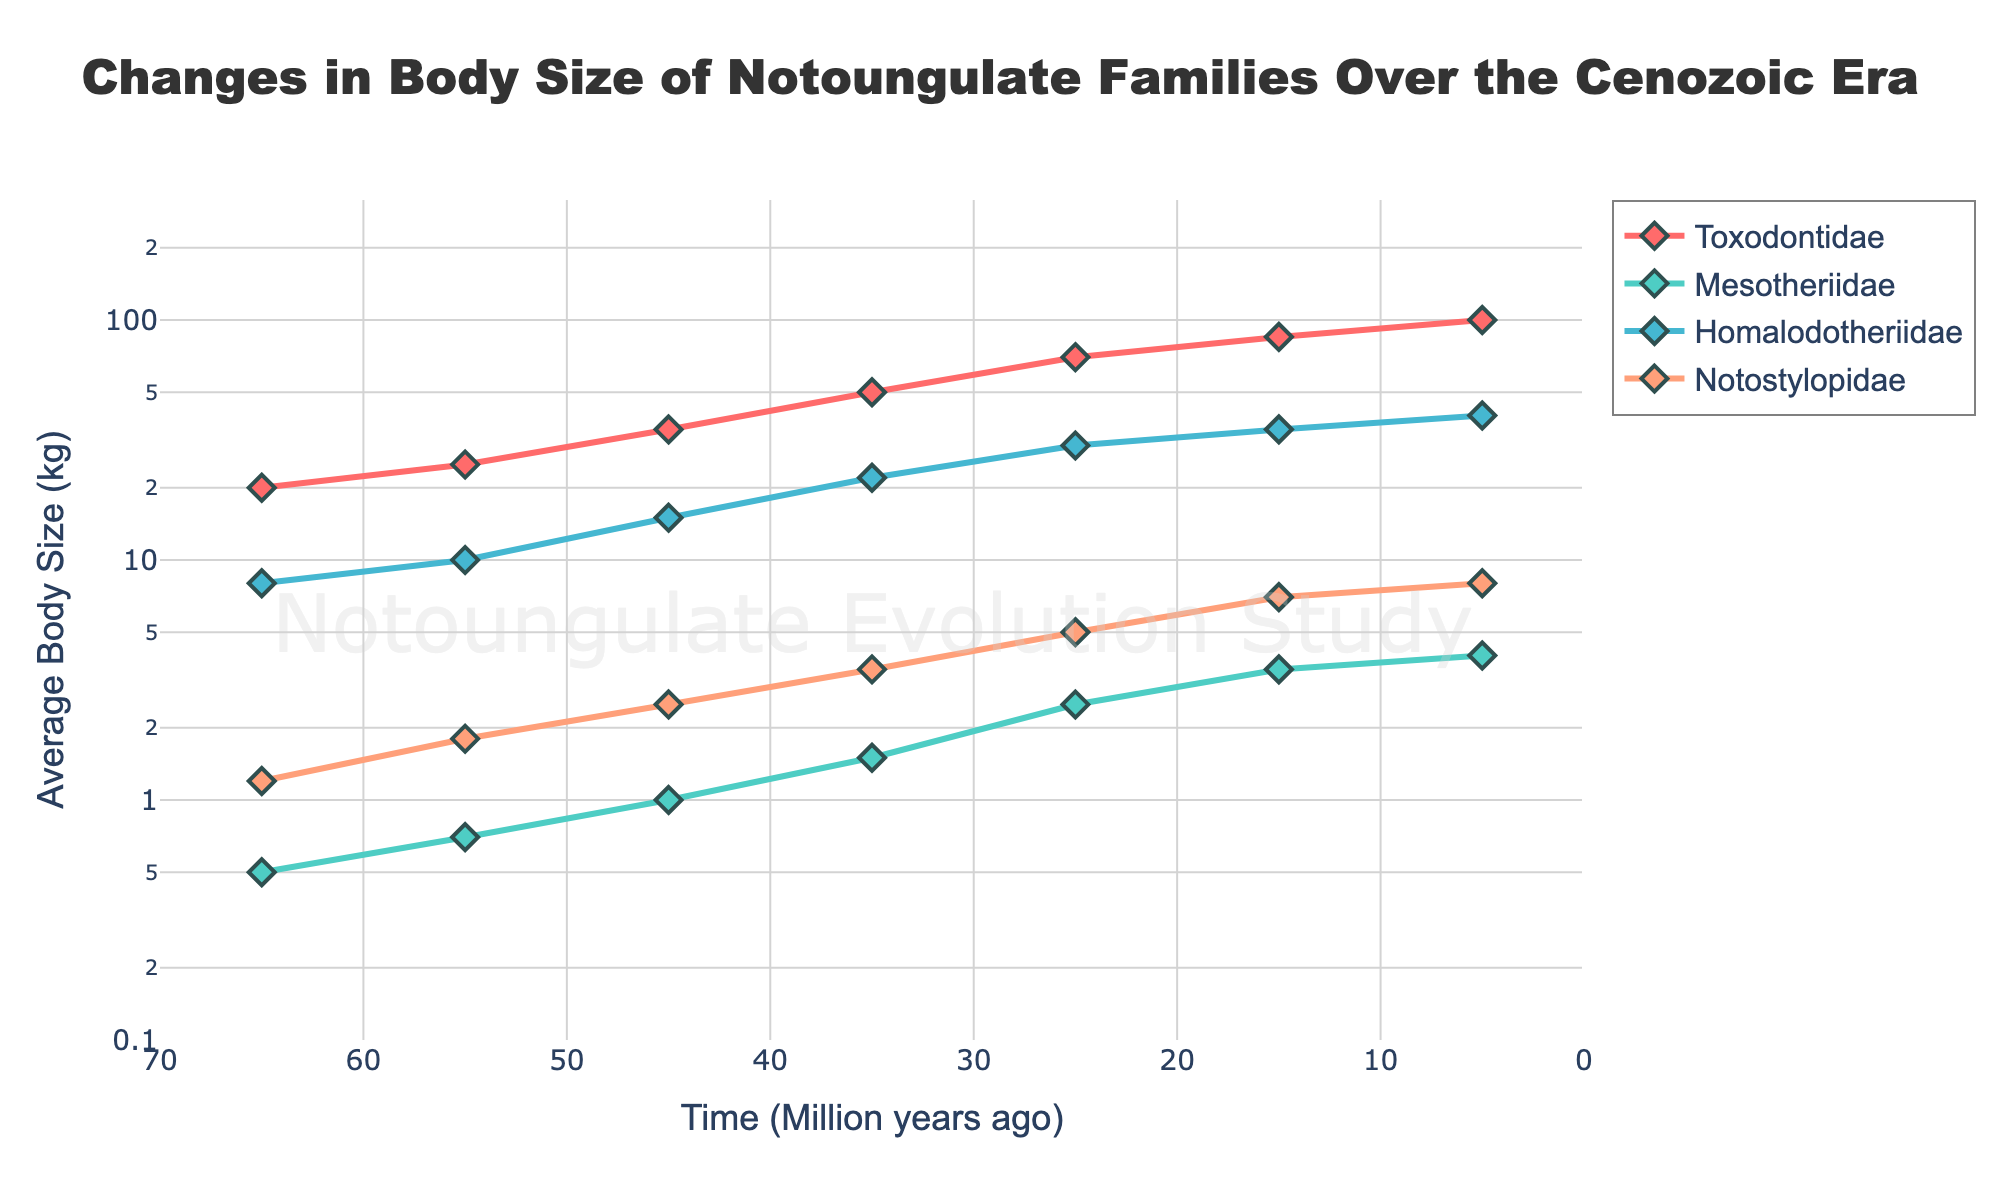What's the title of the plot? The title of the plot is located at the top center of the figure, written in a large font.
Answer: Changes in Body Size of Notoungulate Families Over the Cenozoic Era How many Notoungulate families are depicted in the plot? The legend on the right side of the figure lists the names of each family represented by different colors.
Answer: Four Which Notoungulate family has the largest average body size in the most recent time period? By comparing the y-values at the 5 million years ago (Ma) mark across different lines, Toxodontidae has the highest value.
Answer: Toxodontidae What is the range of the x-axis and y-axis? The x-axis ranges from 70 to 0 million years ago, and the y-axis is represented in a log scale from 0.1 to 300 kg.
Answer: 70 to 0 Ma (x-axis) and 0.1 to 300 kg (y-axis) How does the average body size of Mesotheriidae change from 65 Ma to 5 Ma? Starting at around 0.5 kg (65 Ma) and increasing gradually to 4 kg (5 Ma), indicating a slow but steady rise in size.
Answer: From 0.5 kg to 4 kg Which family shows the most dramatic increase in body size over time? By assessing the slopes of the lines, Toxodontidae exhibits the steepest rise from approximately 20 kg (65 Ma) to 100 kg (5 Ma).
Answer: Toxodontidae Between 35 Ma and 25 Ma, which family saw the greatest relative increase in body size? By seeing the changes between these intervals, Toxodontidae shows a jump from 50 kg to 70 kg.
Answer: Toxodontidae At approximately what time does Homalodotheriidae’s average body size first surpass 30 kg? By tracing the Homalodotheriidae line, the first instance surpassing 30 kg is around 25 Ma.
Answer: 25 Ma Among the families studied, which two have the closest average body size around 65 Ma? Comparing initial y-values, Notostylopidae (1.2 kg) and Mesotheriidae (0.5 kg) are the closest.
Answer: Notostylopidae and Mesotheriidae Which family has the least variation in body size over the Cenozoic Era? By examining the relative change, Mesotheriidae shows the smallest increase in body size.
Answer: Mesotheriidae 